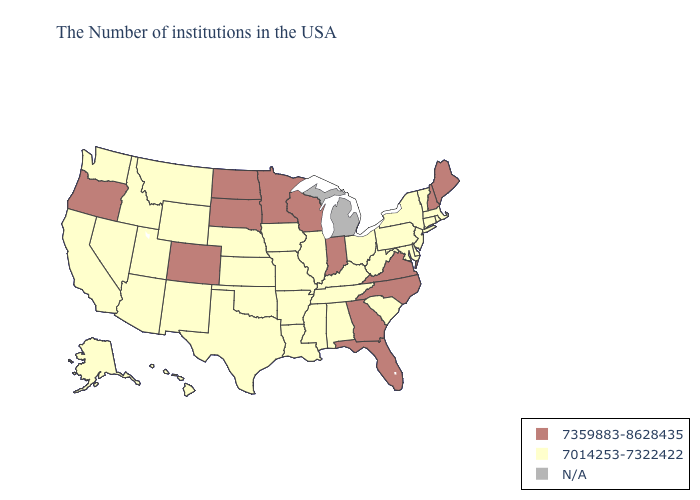What is the value of Florida?
Answer briefly. 7359883-8628435. Name the states that have a value in the range 7014253-7322422?
Give a very brief answer. Massachusetts, Rhode Island, Vermont, Connecticut, New York, New Jersey, Delaware, Maryland, Pennsylvania, South Carolina, West Virginia, Ohio, Kentucky, Alabama, Tennessee, Illinois, Mississippi, Louisiana, Missouri, Arkansas, Iowa, Kansas, Nebraska, Oklahoma, Texas, Wyoming, New Mexico, Utah, Montana, Arizona, Idaho, Nevada, California, Washington, Alaska, Hawaii. Name the states that have a value in the range 7359883-8628435?
Answer briefly. Maine, New Hampshire, Virginia, North Carolina, Florida, Georgia, Indiana, Wisconsin, Minnesota, South Dakota, North Dakota, Colorado, Oregon. Name the states that have a value in the range 7359883-8628435?
Quick response, please. Maine, New Hampshire, Virginia, North Carolina, Florida, Georgia, Indiana, Wisconsin, Minnesota, South Dakota, North Dakota, Colorado, Oregon. Does the first symbol in the legend represent the smallest category?
Keep it brief. No. What is the value of West Virginia?
Answer briefly. 7014253-7322422. Name the states that have a value in the range 7359883-8628435?
Concise answer only. Maine, New Hampshire, Virginia, North Carolina, Florida, Georgia, Indiana, Wisconsin, Minnesota, South Dakota, North Dakota, Colorado, Oregon. Which states have the highest value in the USA?
Short answer required. Maine, New Hampshire, Virginia, North Carolina, Florida, Georgia, Indiana, Wisconsin, Minnesota, South Dakota, North Dakota, Colorado, Oregon. What is the value of New Jersey?
Answer briefly. 7014253-7322422. What is the value of New York?
Answer briefly. 7014253-7322422. Name the states that have a value in the range N/A?
Be succinct. Michigan. What is the value of West Virginia?
Concise answer only. 7014253-7322422. What is the highest value in the USA?
Quick response, please. 7359883-8628435. 